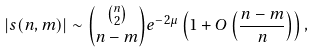<formula> <loc_0><loc_0><loc_500><loc_500>| s ( n , m ) | \sim \binom { \binom { n } { 2 } } { n - m } e ^ { - 2 \mu } \left ( 1 + O \left ( \frac { n - m } { n } \right ) \right ) ,</formula> 